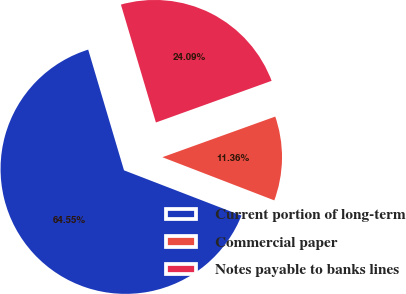<chart> <loc_0><loc_0><loc_500><loc_500><pie_chart><fcel>Current portion of long-term<fcel>Commercial paper<fcel>Notes payable to banks lines<nl><fcel>64.55%<fcel>11.36%<fcel>24.09%<nl></chart> 